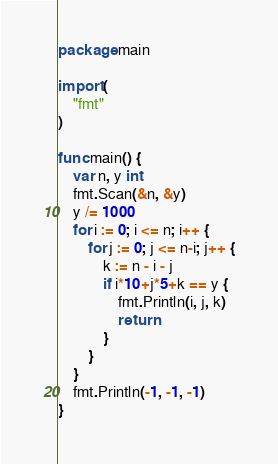Convert code to text. <code><loc_0><loc_0><loc_500><loc_500><_Go_>package main

import (
	"fmt"
)

func main() {
	var n, y int
	fmt.Scan(&n, &y)
	y /= 1000
	for i := 0; i <= n; i++ {
		for j := 0; j <= n-i; j++ {
			k := n - i - j
			if i*10+j*5+k == y {
				fmt.Println(i, j, k)
				return
			}
		}
	}
	fmt.Println(-1, -1, -1)
}
</code> 